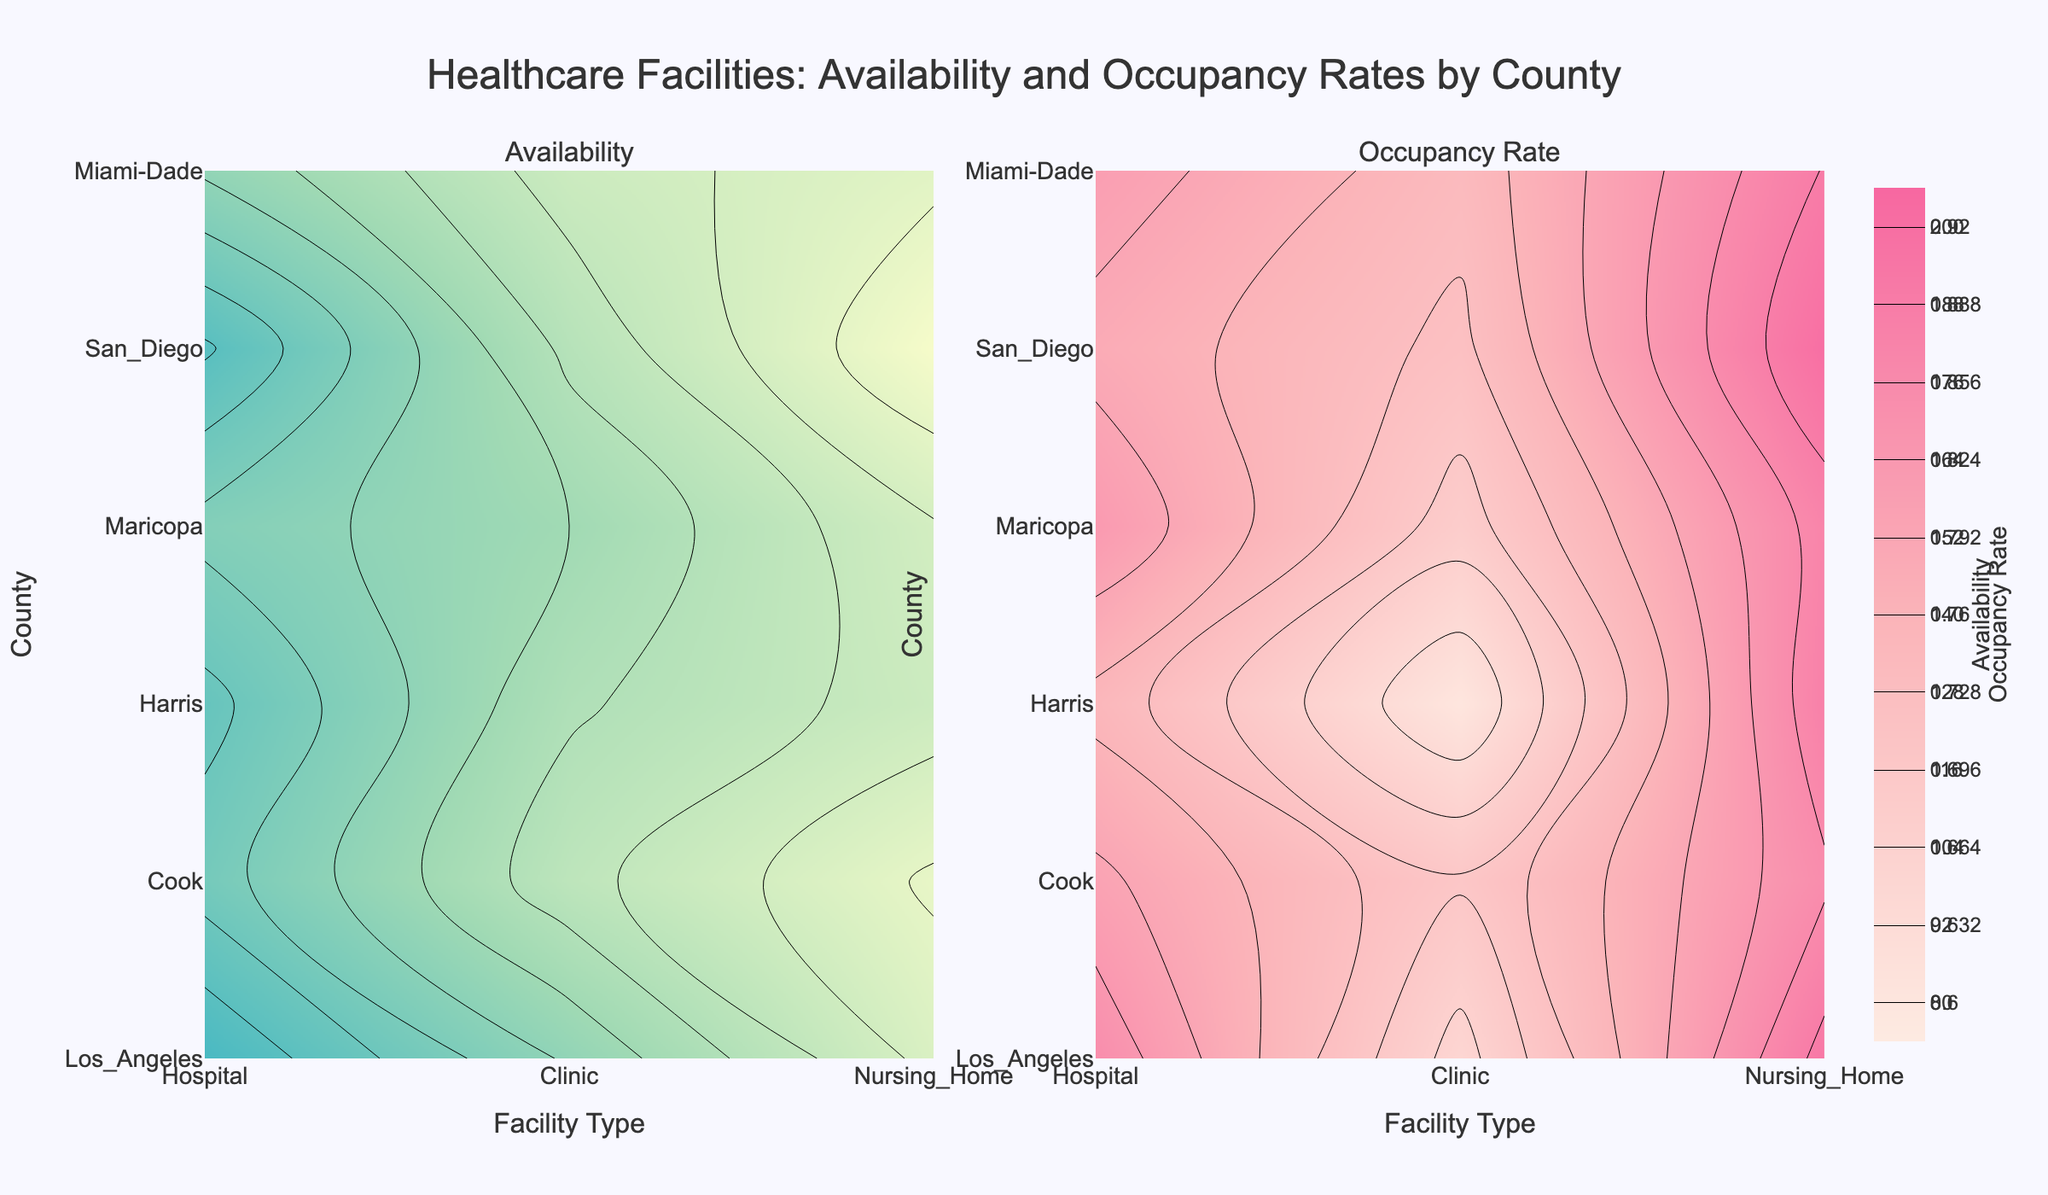What is the title of the figure? The title is usually at the top of the figure. It summarizes what the figure is about.
Answer: Healthcare Facilities: Availability and Occupancy Rates by County Which county shows the highest availability of hospitals? Look at the contour plot for availability on the left, and identify the highest value on the z-axis, then trace back to the corresponding county on the y-axis and the facility type "Hospital" on the x-axis.
Answer: Los_Angeles Which facility type has the highest occupancy rate in Maricopa county? Look at the contour plot for occupancy rates on the right, locate the area corresponding to Maricopa county on the y-axis, and identify the highest value on the z-axis. Then trace back to the corresponding facility type on the x-axis.
Answer: Nursing_Home Which county has a lower occupancy rate for clinics, Los Angeles or Cook? Compare the values in the contour plot for occupancy rates on the right for the counties Los Angeles and Cook under the facility type "Clinic."
Answer: Los_Angeles How does the availability of nursing homes in Miami-Dade compare to that in San Diego? Look at the contour plot for availability and compare the availability values for nursing homes in Miami-Dade and San Diego counties by inspecting the respective positions on the plot.
Answer: Miami-Dade has higher availability than San Diego What is the color range for availability in the contour plot? Look at the color scale on the left contour plot. The colors range from light yellow for lower availability to dark blue for higher availability.
Answer: light yellow to dark blue Is the occupancy rate for hospitals in Harris county above 0.8? Determine the value for hospitals in Harris county in the contour plot for occupancy rates on the right, and see if it is above or below 0.8.
Answer: No Which county has both the highest availability and highest occupancy rate for nursing homes? Identify the highest availability and highest occupancy rate for nursing homes by examining both contour plots, and see which county matches both criteria.
Answer: San Diego Comparing availability and occupancy, which facility type shows the greatest discrepancy in Harris county? Examine the values for both availability (left plot) and occupancy rates (right plot) for Harris county across different facility types and determine where the difference between availability and occupancy is the greatest.
Answer: Clinic 